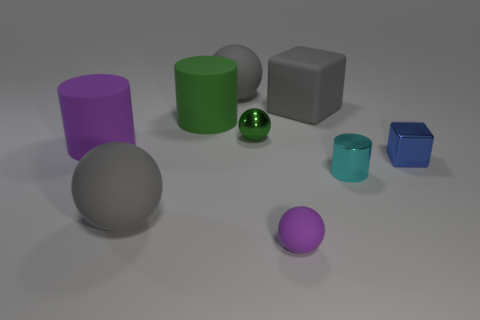Describe the lighting conditions in the scene. The lighting in the image is soft and diffused, with no harsh shadows or bright highlights, which gives the scene a calm and uniform ambiance. The source of the light isn't directly visible, but it appears to be coming from above based on the gentle shadows beneath the objects. This type of lighting is consistent with an indoor setting that is well-lit, possibly with ambient light or soft studio lighting. Does the lighting affect the appearance of the materials? Yes, the diffuse lighting conditions play a significant role in revealing the textures and finishes of the objects. For instance, the matte surfaces of the gray items don't reflect much light, thus emphasizing their non-glossy texture. Conversely, the shiny green sphere reflects light strongly, highlighting its smooth and reflective material. The interplay of light and shadow can greatly influence our perception of an object's material in any given environment. 